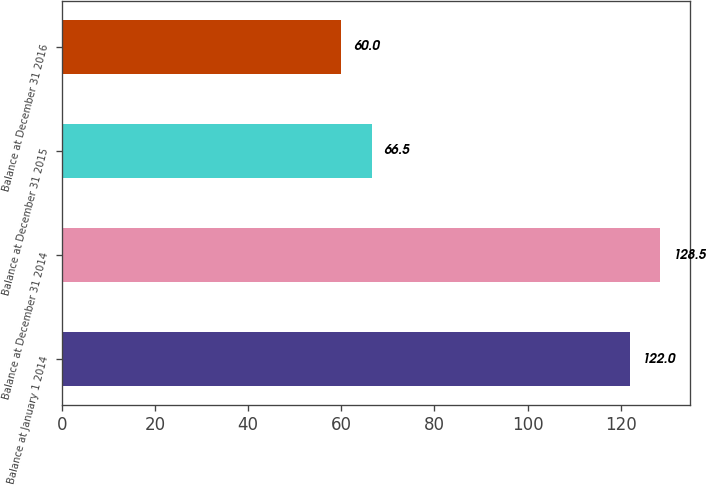Convert chart to OTSL. <chart><loc_0><loc_0><loc_500><loc_500><bar_chart><fcel>Balance at January 1 2014<fcel>Balance at December 31 2014<fcel>Balance at December 31 2015<fcel>Balance at December 31 2016<nl><fcel>122<fcel>128.5<fcel>66.5<fcel>60<nl></chart> 